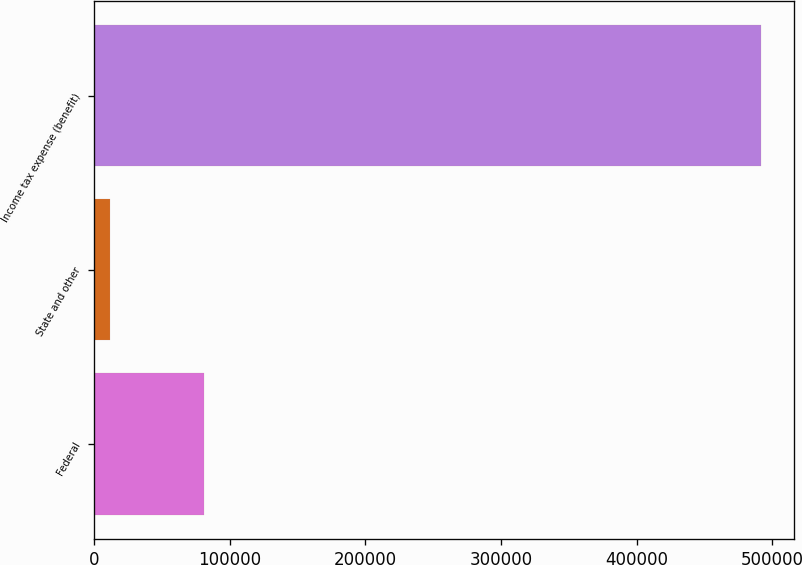Convert chart to OTSL. <chart><loc_0><loc_0><loc_500><loc_500><bar_chart><fcel>Federal<fcel>State and other<fcel>Income tax expense (benefit)<nl><fcel>81101<fcel>11801<fcel>491607<nl></chart> 